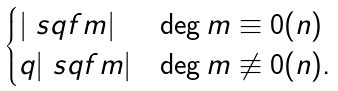Convert formula to latex. <formula><loc_0><loc_0><loc_500><loc_500>\begin{cases} | \ s q f { m } | & \deg m \equiv 0 ( n ) \\ q | \ s q f { m } | & \deg m \not \equiv 0 ( n ) . \\ \end{cases}</formula> 